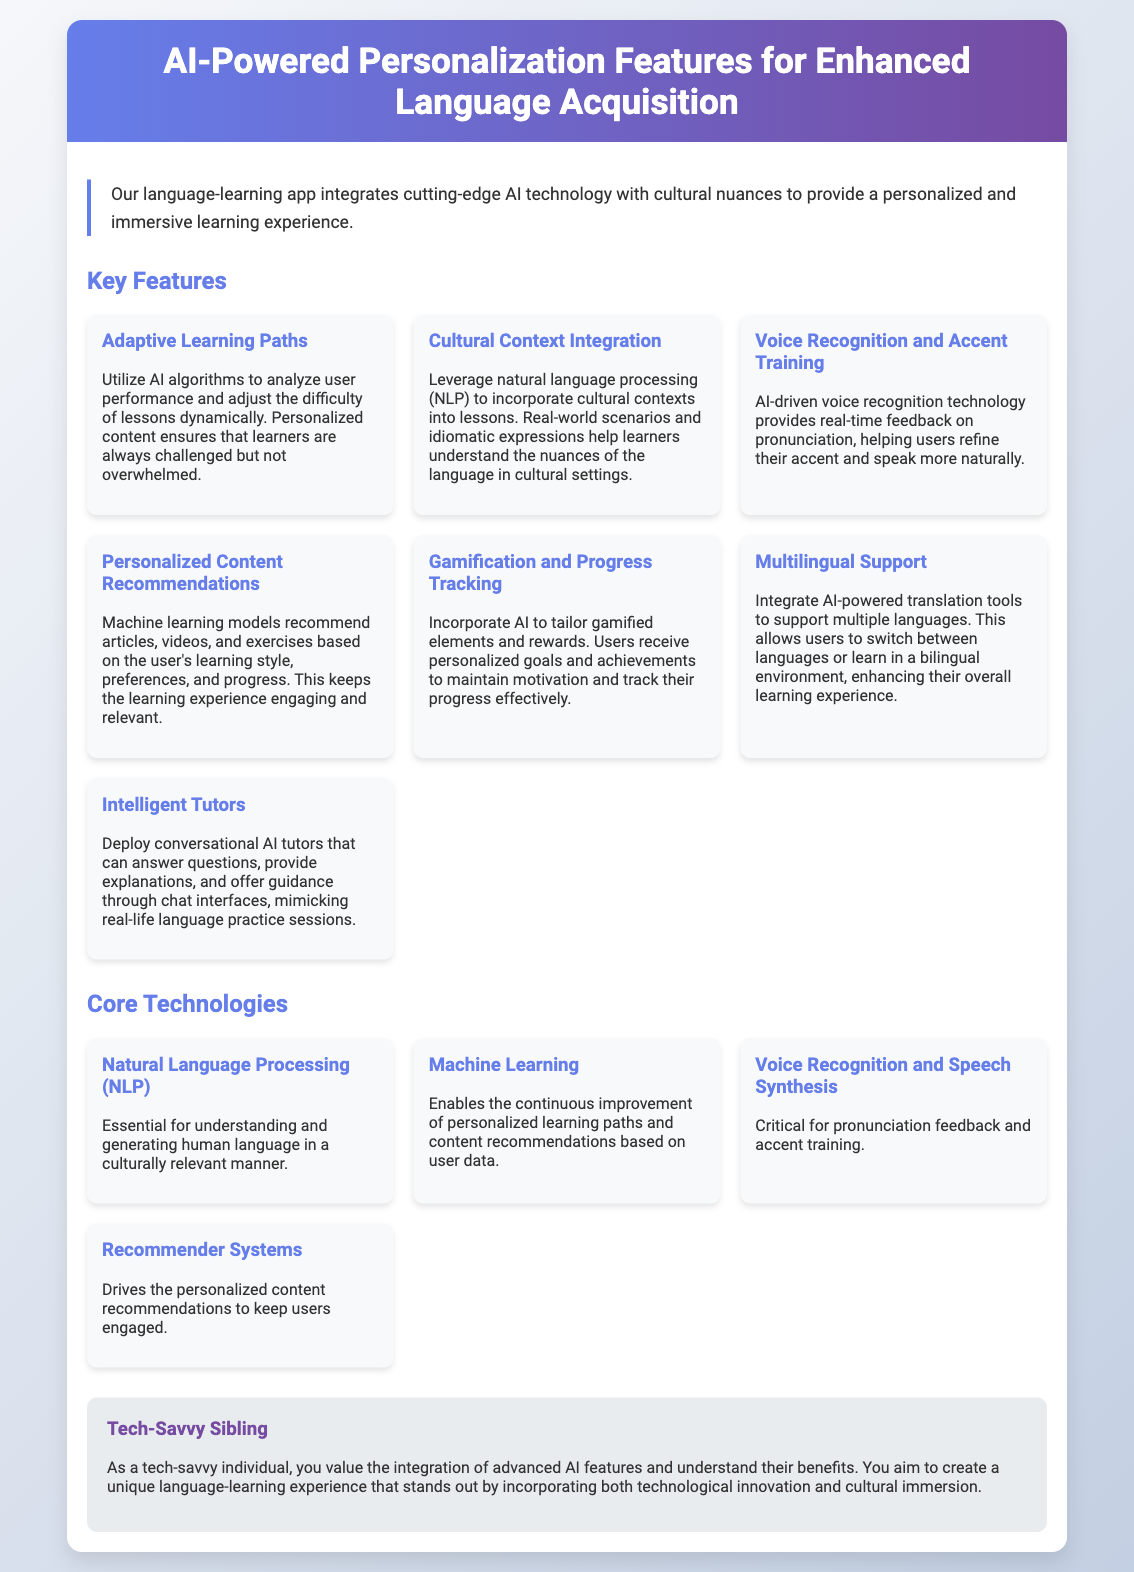What is the title of the document? The title is displayed in the header section of the document.
Answer: AI-Powered Personalization Features for Enhanced Language Acquisition How many key features are listed in the document? The document presents a section titled "Key Features" which includes multiple individual features.
Answer: Seven What technology is essential for understanding human language? The document specifies a core technology crucial for language understanding.
Answer: Natural Language Processing (NLP) What does the app offer for pronunciation improvement? The document mentions a specific feature related to pronunciation feedback and training.
Answer: Voice Recognition and Accent Training Which machine learning aspect is highlighted for improving user experience? The document notes a specific focus of machine learning in personalized learning paths.
Answer: Recommendations What describes the user persona in the document? The user persona section outlines a specific type of user that relates to the app's technology.
Answer: Tech-Savvy Sibling How does the app enhance motivation for users? The document refers to a feature that helps maintain user motivation and engagement.
Answer: Gamification and Progress Tracking 